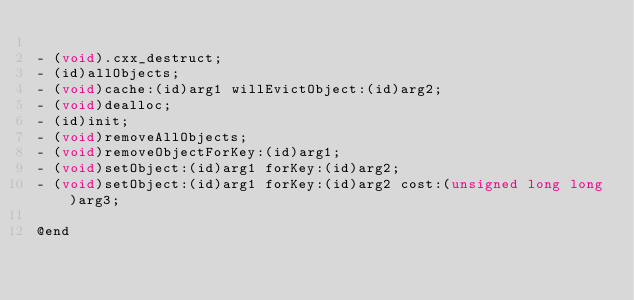<code> <loc_0><loc_0><loc_500><loc_500><_C_>
- (void).cxx_destruct;
- (id)allObjects;
- (void)cache:(id)arg1 willEvictObject:(id)arg2;
- (void)dealloc;
- (id)init;
- (void)removeAllObjects;
- (void)removeObjectForKey:(id)arg1;
- (void)setObject:(id)arg1 forKey:(id)arg2;
- (void)setObject:(id)arg1 forKey:(id)arg2 cost:(unsigned long long)arg3;

@end
</code> 